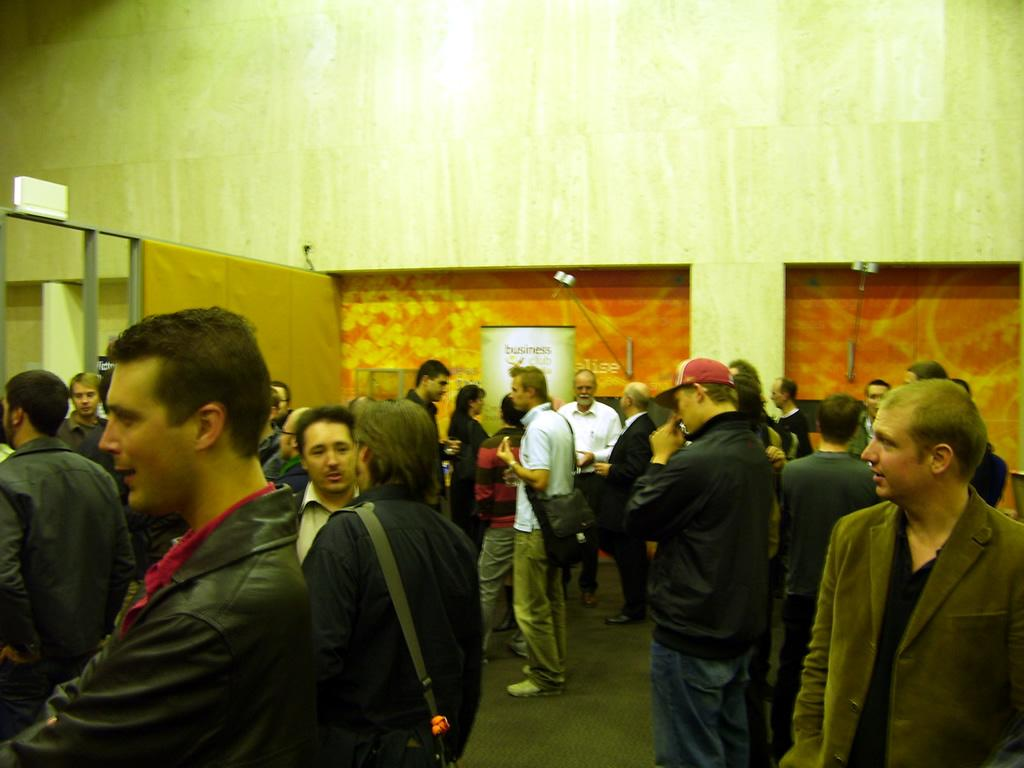How many people are in the image? There is a group of people in the image. What are the people doing in the image? The people are standing on the floor. What object can be seen in the image besides the people? There is a bag and a poster visible in the image. What can be seen in the background of the image? There is a wall visible in the background of the image. How many rabbits are visible in the image? There are no rabbits present in the image. What type of spiders can be seen crawling on the wall in the image? There are no spiders visible in the image; only a wall is present in the background. 